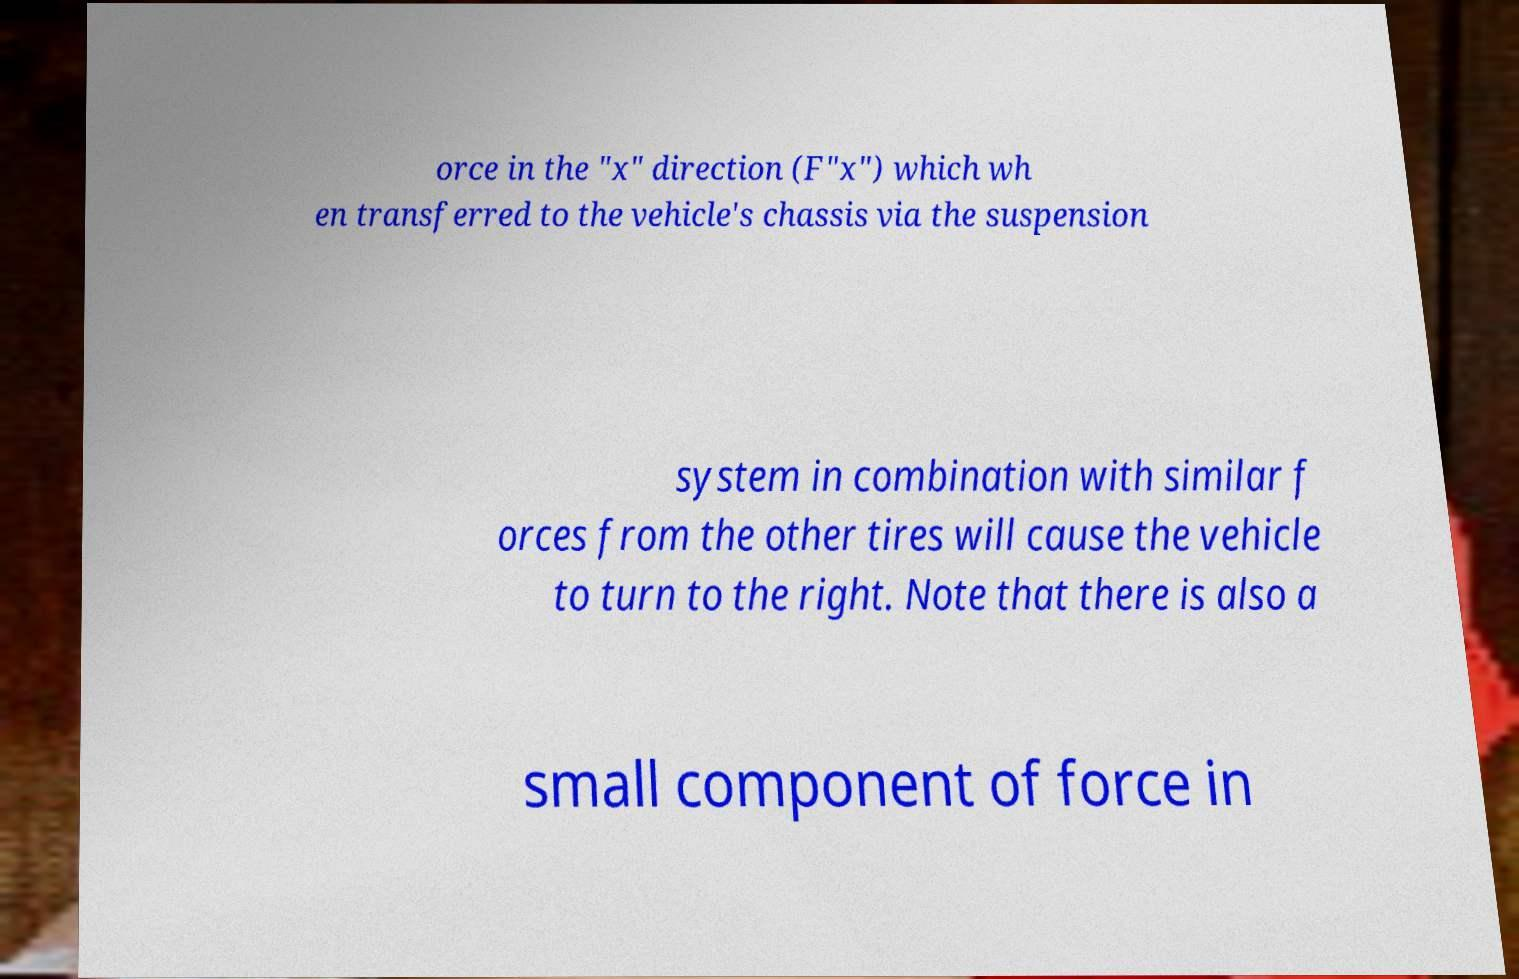Please read and relay the text visible in this image. What does it say? orce in the "x" direction (F"x") which wh en transferred to the vehicle's chassis via the suspension system in combination with similar f orces from the other tires will cause the vehicle to turn to the right. Note that there is also a small component of force in 